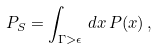<formula> <loc_0><loc_0><loc_500><loc_500>P _ { S } = \int _ { \Gamma > \epsilon } \, d x \, P ( x ) \, ,</formula> 